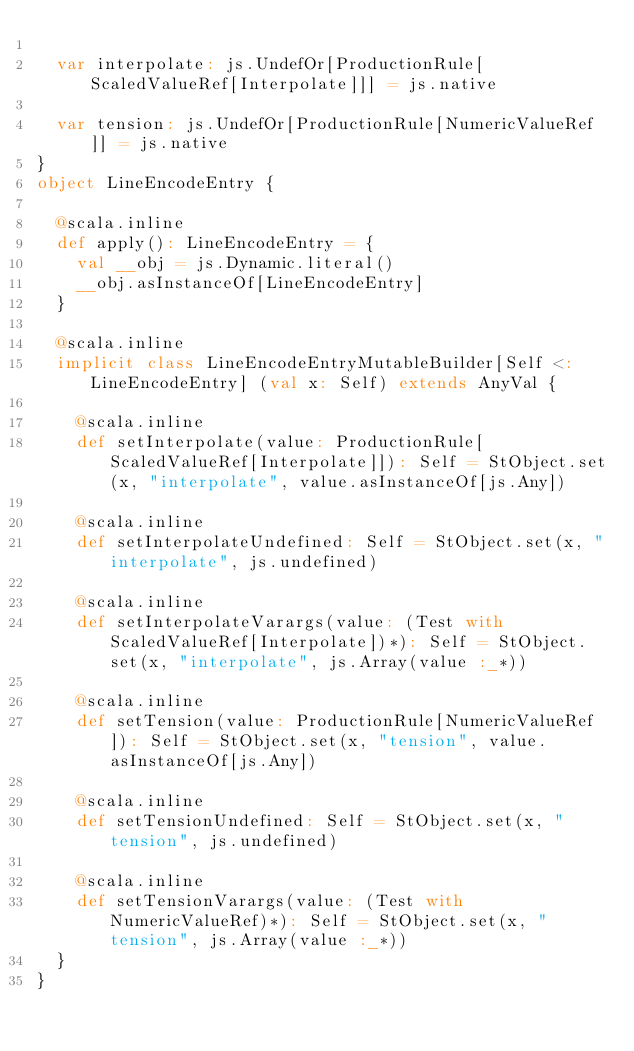<code> <loc_0><loc_0><loc_500><loc_500><_Scala_>  
  var interpolate: js.UndefOr[ProductionRule[ScaledValueRef[Interpolate]]] = js.native
  
  var tension: js.UndefOr[ProductionRule[NumericValueRef]] = js.native
}
object LineEncodeEntry {
  
  @scala.inline
  def apply(): LineEncodeEntry = {
    val __obj = js.Dynamic.literal()
    __obj.asInstanceOf[LineEncodeEntry]
  }
  
  @scala.inline
  implicit class LineEncodeEntryMutableBuilder[Self <: LineEncodeEntry] (val x: Self) extends AnyVal {
    
    @scala.inline
    def setInterpolate(value: ProductionRule[ScaledValueRef[Interpolate]]): Self = StObject.set(x, "interpolate", value.asInstanceOf[js.Any])
    
    @scala.inline
    def setInterpolateUndefined: Self = StObject.set(x, "interpolate", js.undefined)
    
    @scala.inline
    def setInterpolateVarargs(value: (Test with ScaledValueRef[Interpolate])*): Self = StObject.set(x, "interpolate", js.Array(value :_*))
    
    @scala.inline
    def setTension(value: ProductionRule[NumericValueRef]): Self = StObject.set(x, "tension", value.asInstanceOf[js.Any])
    
    @scala.inline
    def setTensionUndefined: Self = StObject.set(x, "tension", js.undefined)
    
    @scala.inline
    def setTensionVarargs(value: (Test with NumericValueRef)*): Self = StObject.set(x, "tension", js.Array(value :_*))
  }
}
</code> 